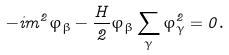Convert formula to latex. <formula><loc_0><loc_0><loc_500><loc_500>- i m ^ { 2 } \varphi _ { \beta } - \frac { H } { 2 } \varphi _ { \beta } \sum _ { \gamma } \varphi _ { \gamma } ^ { 2 } = 0 .</formula> 